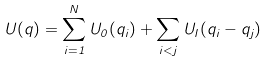<formula> <loc_0><loc_0><loc_500><loc_500>U ( q ) = \sum _ { i = 1 } ^ { N } U _ { 0 } ( q _ { i } ) + \sum _ { i < j } U _ { I } ( q _ { i } - q _ { j } )</formula> 